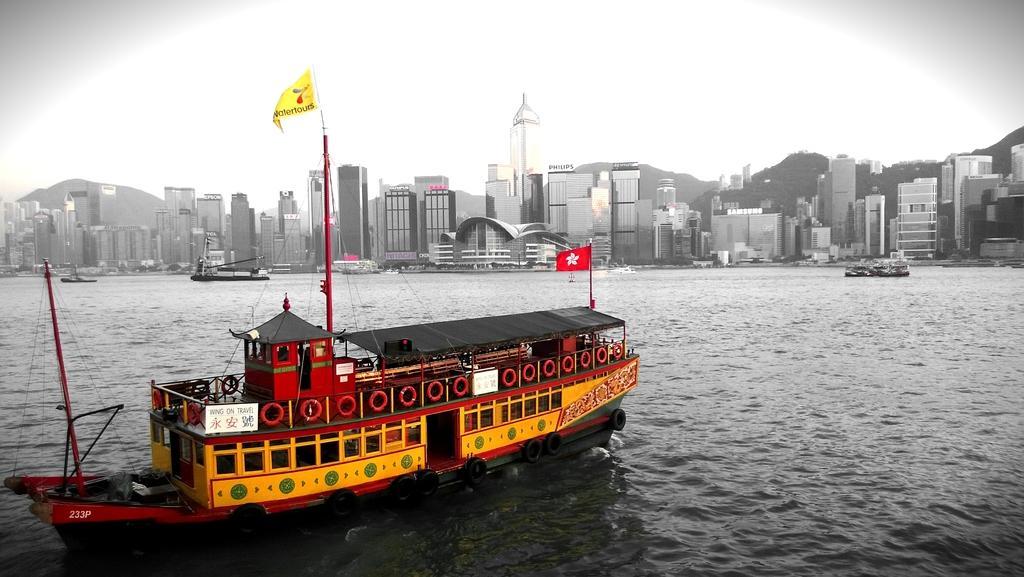Please provide a concise description of this image. In front of the picture, we see a boat in red and yellow color is sailing on the water. We even see the flagpoles and flags in yellow and red color. There are ships sailing on the water. There are trees, buildings and hills in the background. At the top, we see the sky. 